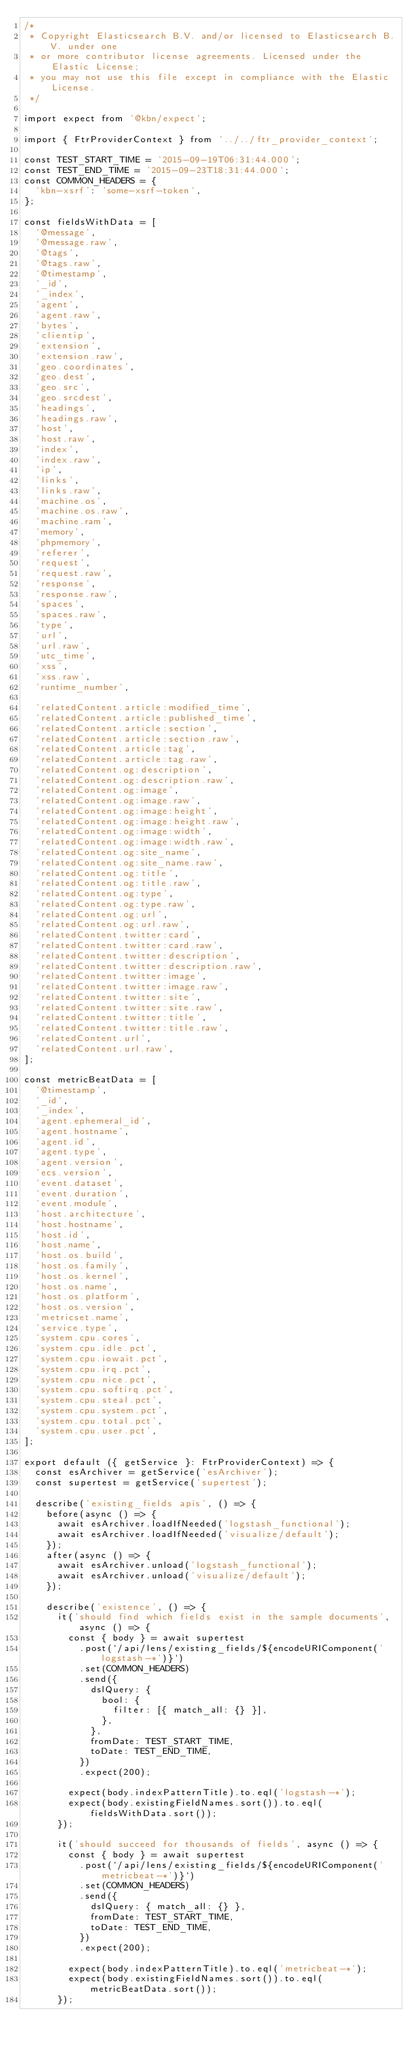<code> <loc_0><loc_0><loc_500><loc_500><_TypeScript_>/*
 * Copyright Elasticsearch B.V. and/or licensed to Elasticsearch B.V. under one
 * or more contributor license agreements. Licensed under the Elastic License;
 * you may not use this file except in compliance with the Elastic License.
 */

import expect from '@kbn/expect';

import { FtrProviderContext } from '../../ftr_provider_context';

const TEST_START_TIME = '2015-09-19T06:31:44.000';
const TEST_END_TIME = '2015-09-23T18:31:44.000';
const COMMON_HEADERS = {
  'kbn-xsrf': 'some-xsrf-token',
};

const fieldsWithData = [
  '@message',
  '@message.raw',
  '@tags',
  '@tags.raw',
  '@timestamp',
  '_id',
  '_index',
  'agent',
  'agent.raw',
  'bytes',
  'clientip',
  'extension',
  'extension.raw',
  'geo.coordinates',
  'geo.dest',
  'geo.src',
  'geo.srcdest',
  'headings',
  'headings.raw',
  'host',
  'host.raw',
  'index',
  'index.raw',
  'ip',
  'links',
  'links.raw',
  'machine.os',
  'machine.os.raw',
  'machine.ram',
  'memory',
  'phpmemory',
  'referer',
  'request',
  'request.raw',
  'response',
  'response.raw',
  'spaces',
  'spaces.raw',
  'type',
  'url',
  'url.raw',
  'utc_time',
  'xss',
  'xss.raw',
  'runtime_number',

  'relatedContent.article:modified_time',
  'relatedContent.article:published_time',
  'relatedContent.article:section',
  'relatedContent.article:section.raw',
  'relatedContent.article:tag',
  'relatedContent.article:tag.raw',
  'relatedContent.og:description',
  'relatedContent.og:description.raw',
  'relatedContent.og:image',
  'relatedContent.og:image.raw',
  'relatedContent.og:image:height',
  'relatedContent.og:image:height.raw',
  'relatedContent.og:image:width',
  'relatedContent.og:image:width.raw',
  'relatedContent.og:site_name',
  'relatedContent.og:site_name.raw',
  'relatedContent.og:title',
  'relatedContent.og:title.raw',
  'relatedContent.og:type',
  'relatedContent.og:type.raw',
  'relatedContent.og:url',
  'relatedContent.og:url.raw',
  'relatedContent.twitter:card',
  'relatedContent.twitter:card.raw',
  'relatedContent.twitter:description',
  'relatedContent.twitter:description.raw',
  'relatedContent.twitter:image',
  'relatedContent.twitter:image.raw',
  'relatedContent.twitter:site',
  'relatedContent.twitter:site.raw',
  'relatedContent.twitter:title',
  'relatedContent.twitter:title.raw',
  'relatedContent.url',
  'relatedContent.url.raw',
];

const metricBeatData = [
  '@timestamp',
  '_id',
  '_index',
  'agent.ephemeral_id',
  'agent.hostname',
  'agent.id',
  'agent.type',
  'agent.version',
  'ecs.version',
  'event.dataset',
  'event.duration',
  'event.module',
  'host.architecture',
  'host.hostname',
  'host.id',
  'host.name',
  'host.os.build',
  'host.os.family',
  'host.os.kernel',
  'host.os.name',
  'host.os.platform',
  'host.os.version',
  'metricset.name',
  'service.type',
  'system.cpu.cores',
  'system.cpu.idle.pct',
  'system.cpu.iowait.pct',
  'system.cpu.irq.pct',
  'system.cpu.nice.pct',
  'system.cpu.softirq.pct',
  'system.cpu.steal.pct',
  'system.cpu.system.pct',
  'system.cpu.total.pct',
  'system.cpu.user.pct',
];

export default ({ getService }: FtrProviderContext) => {
  const esArchiver = getService('esArchiver');
  const supertest = getService('supertest');

  describe('existing_fields apis', () => {
    before(async () => {
      await esArchiver.loadIfNeeded('logstash_functional');
      await esArchiver.loadIfNeeded('visualize/default');
    });
    after(async () => {
      await esArchiver.unload('logstash_functional');
      await esArchiver.unload('visualize/default');
    });

    describe('existence', () => {
      it('should find which fields exist in the sample documents', async () => {
        const { body } = await supertest
          .post(`/api/lens/existing_fields/${encodeURIComponent('logstash-*')}`)
          .set(COMMON_HEADERS)
          .send({
            dslQuery: {
              bool: {
                filter: [{ match_all: {} }],
              },
            },
            fromDate: TEST_START_TIME,
            toDate: TEST_END_TIME,
          })
          .expect(200);

        expect(body.indexPatternTitle).to.eql('logstash-*');
        expect(body.existingFieldNames.sort()).to.eql(fieldsWithData.sort());
      });

      it('should succeed for thousands of fields', async () => {
        const { body } = await supertest
          .post(`/api/lens/existing_fields/${encodeURIComponent('metricbeat-*')}`)
          .set(COMMON_HEADERS)
          .send({
            dslQuery: { match_all: {} },
            fromDate: TEST_START_TIME,
            toDate: TEST_END_TIME,
          })
          .expect(200);

        expect(body.indexPatternTitle).to.eql('metricbeat-*');
        expect(body.existingFieldNames.sort()).to.eql(metricBeatData.sort());
      });
</code> 